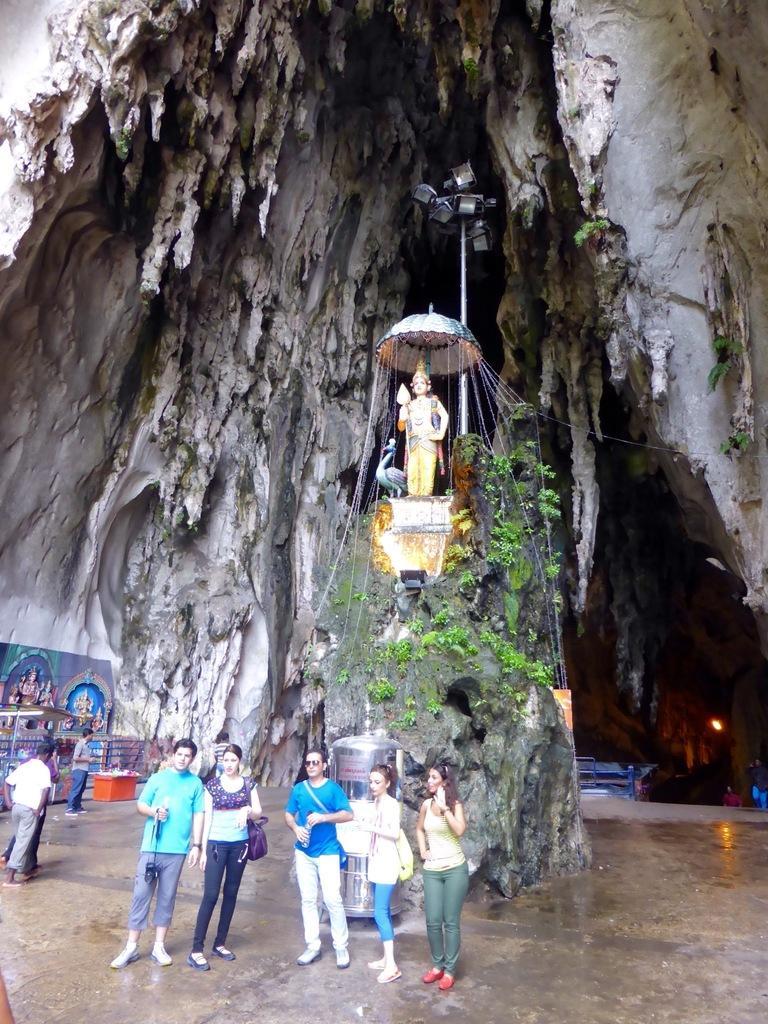In one or two sentences, can you explain what this image depicts? In this image there are five persons standing, in the background there is a rock, on that rock there is a statute, on above that there is cave. 